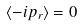<formula> <loc_0><loc_0><loc_500><loc_500>\langle - i p _ { r } \rangle = 0</formula> 